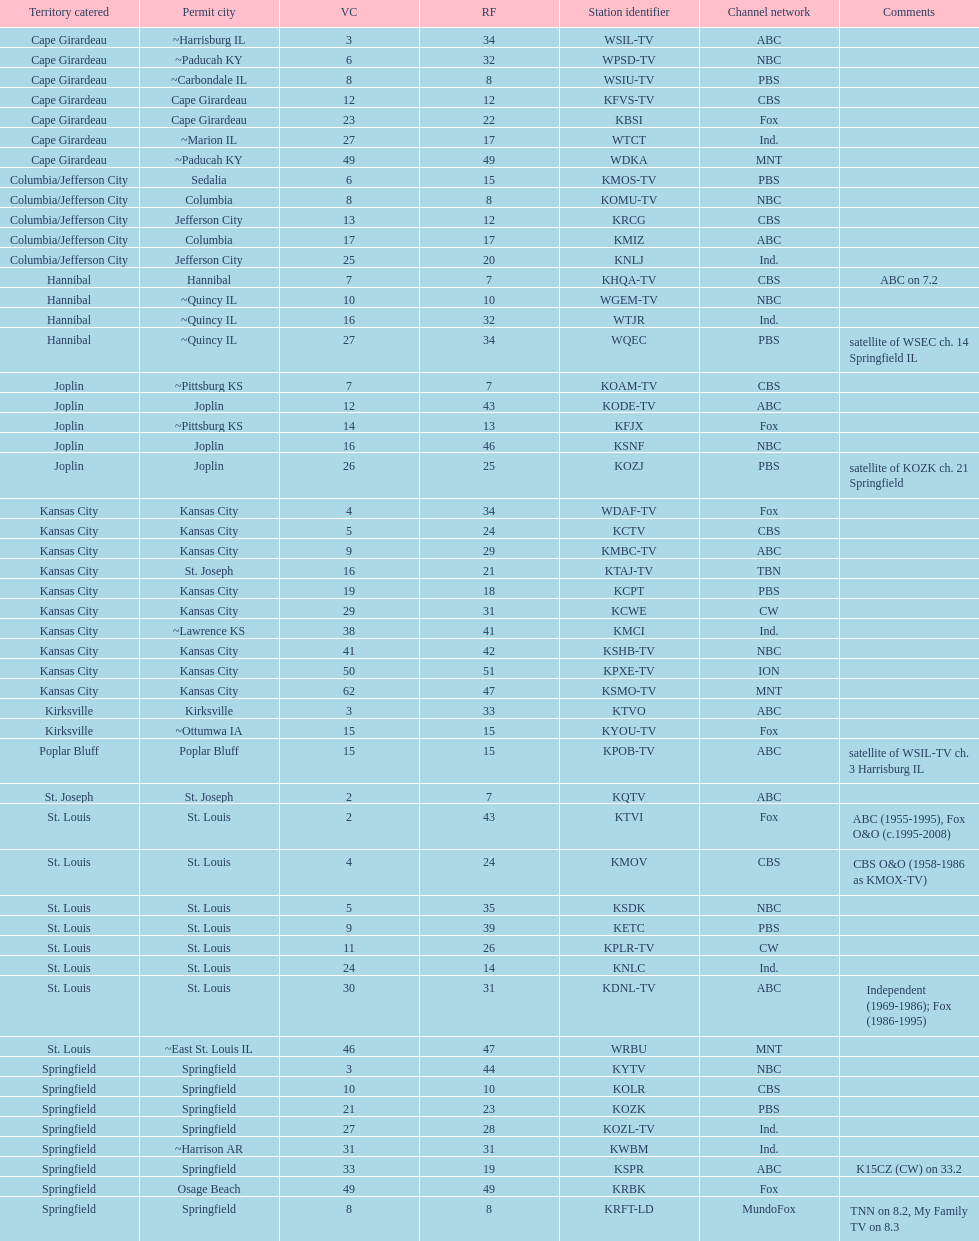Which station holds a license in the identical city as koam-tv? KFJX. 